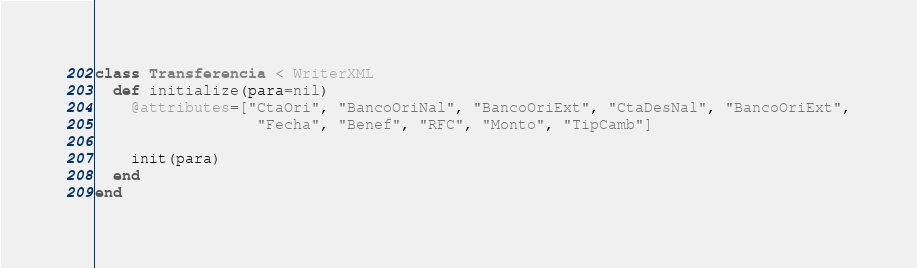<code> <loc_0><loc_0><loc_500><loc_500><_Ruby_>class Transferencia < WriterXML
  def initialize(para=nil)
    @attributes=["CtaOri", "BancoOriNal", "BancoOriExt", "CtaDesNal", "BancoOriExt",
                  "Fecha", "Benef", "RFC", "Monto", "TipCamb"]

    init(para)
  end
end
</code> 